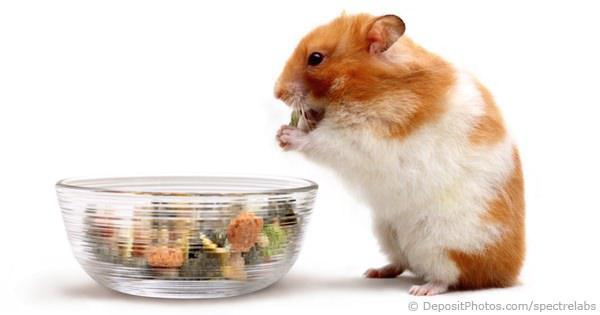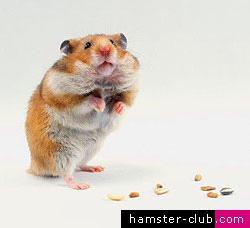The first image is the image on the left, the second image is the image on the right. For the images shown, is this caption "A hamster is eating off a clear bowl full of food." true? Answer yes or no. Yes. The first image is the image on the left, the second image is the image on the right. For the images shown, is this caption "An image shows an orange-and-white hamster next to a clear bowl of food." true? Answer yes or no. Yes. 